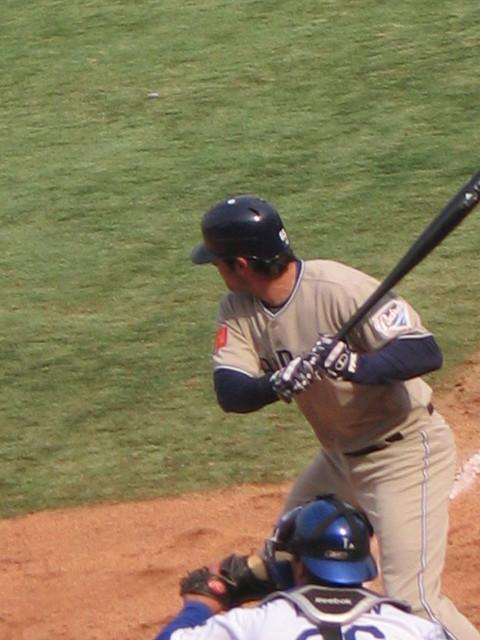What action is the man wearing blue hat doing? Please explain your reasoning. crouching. He is bent over so he can catch the ball if it goes to him. 